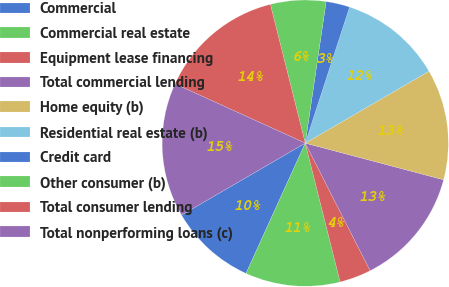<chart> <loc_0><loc_0><loc_500><loc_500><pie_chart><fcel>Commercial<fcel>Commercial real estate<fcel>Equipment lease financing<fcel>Total commercial lending<fcel>Home equity (b)<fcel>Residential real estate (b)<fcel>Credit card<fcel>Other consumer (b)<fcel>Total consumer lending<fcel>Total nonperforming loans (c)<nl><fcel>9.82%<fcel>10.71%<fcel>3.57%<fcel>13.39%<fcel>12.5%<fcel>11.61%<fcel>2.68%<fcel>6.25%<fcel>14.28%<fcel>15.18%<nl></chart> 